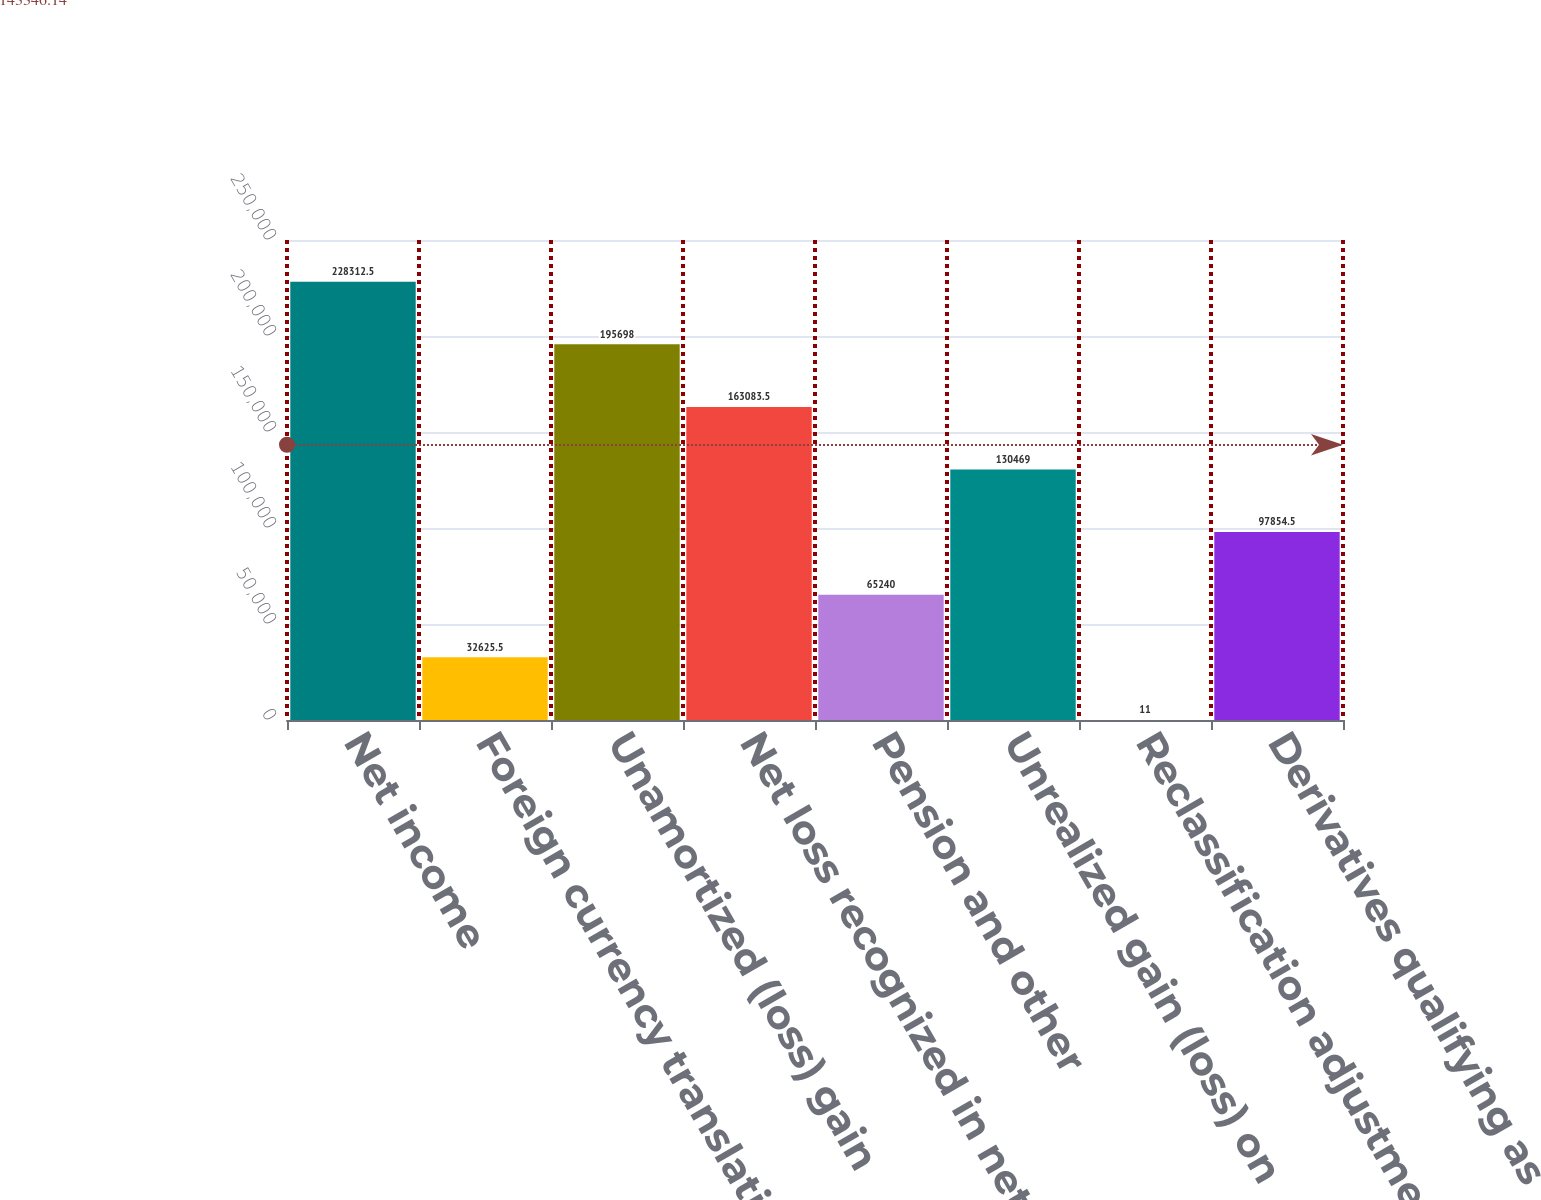Convert chart to OTSL. <chart><loc_0><loc_0><loc_500><loc_500><bar_chart><fcel>Net income<fcel>Foreign currency translation<fcel>Unamortized (loss) gain<fcel>Net loss recognized in net<fcel>Pension and other<fcel>Unrealized gain (loss) on<fcel>Reclassification adjustment on<fcel>Derivatives qualifying as<nl><fcel>228312<fcel>32625.5<fcel>195698<fcel>163084<fcel>65240<fcel>130469<fcel>11<fcel>97854.5<nl></chart> 